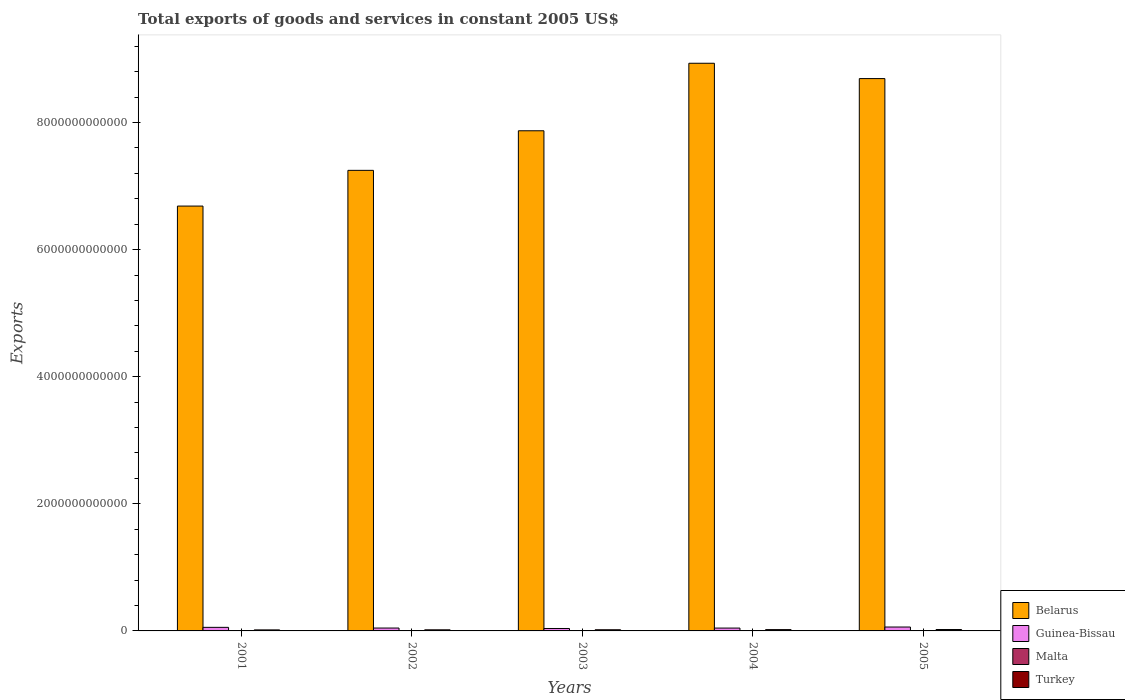Are the number of bars on each tick of the X-axis equal?
Offer a very short reply. Yes. What is the label of the 2nd group of bars from the left?
Your answer should be compact. 2002. What is the total exports of goods and services in Belarus in 2002?
Provide a succinct answer. 7.25e+12. Across all years, what is the maximum total exports of goods and services in Malta?
Give a very brief answer. 3.70e+09. Across all years, what is the minimum total exports of goods and services in Malta?
Offer a very short reply. 3.44e+09. What is the total total exports of goods and services in Guinea-Bissau in the graph?
Your answer should be compact. 2.46e+11. What is the difference between the total exports of goods and services in Malta in 2001 and that in 2002?
Your answer should be compact. -2.27e+08. What is the difference between the total exports of goods and services in Malta in 2005 and the total exports of goods and services in Guinea-Bissau in 2004?
Offer a very short reply. -4.11e+1. What is the average total exports of goods and services in Turkey per year?
Provide a short and direct response. 1.89e+1. In the year 2004, what is the difference between the total exports of goods and services in Belarus and total exports of goods and services in Guinea-Bissau?
Provide a succinct answer. 8.89e+12. What is the ratio of the total exports of goods and services in Belarus in 2001 to that in 2002?
Offer a very short reply. 0.92. Is the total exports of goods and services in Malta in 2001 less than that in 2004?
Offer a terse response. Yes. Is the difference between the total exports of goods and services in Belarus in 2002 and 2005 greater than the difference between the total exports of goods and services in Guinea-Bissau in 2002 and 2005?
Provide a succinct answer. No. What is the difference between the highest and the second highest total exports of goods and services in Turkey?
Your response must be concise. 1.62e+09. What is the difference between the highest and the lowest total exports of goods and services in Malta?
Provide a succinct answer. 2.62e+08. In how many years, is the total exports of goods and services in Malta greater than the average total exports of goods and services in Malta taken over all years?
Your answer should be compact. 3. Is the sum of the total exports of goods and services in Guinea-Bissau in 2004 and 2005 greater than the maximum total exports of goods and services in Turkey across all years?
Keep it short and to the point. Yes. What does the 3rd bar from the left in 2002 represents?
Your answer should be compact. Malta. What does the 4th bar from the right in 2004 represents?
Your answer should be very brief. Belarus. How many bars are there?
Ensure brevity in your answer.  20. How many years are there in the graph?
Your answer should be very brief. 5. What is the difference between two consecutive major ticks on the Y-axis?
Provide a short and direct response. 2.00e+12. Does the graph contain any zero values?
Offer a terse response. No. Where does the legend appear in the graph?
Make the answer very short. Bottom right. How many legend labels are there?
Provide a succinct answer. 4. How are the legend labels stacked?
Keep it short and to the point. Vertical. What is the title of the graph?
Give a very brief answer. Total exports of goods and services in constant 2005 US$. Does "Libya" appear as one of the legend labels in the graph?
Ensure brevity in your answer.  No. What is the label or title of the X-axis?
Your answer should be compact. Years. What is the label or title of the Y-axis?
Give a very brief answer. Exports. What is the Exports in Belarus in 2001?
Provide a short and direct response. 6.69e+12. What is the Exports of Guinea-Bissau in 2001?
Offer a terse response. 5.61e+1. What is the Exports of Malta in 2001?
Provide a short and direct response. 3.44e+09. What is the Exports in Turkey in 2001?
Offer a very short reply. 1.61e+1. What is the Exports of Belarus in 2002?
Offer a terse response. 7.25e+12. What is the Exports of Guinea-Bissau in 2002?
Ensure brevity in your answer.  4.53e+1. What is the Exports in Malta in 2002?
Provide a succinct answer. 3.67e+09. What is the Exports of Turkey in 2002?
Offer a very short reply. 1.72e+1. What is the Exports of Belarus in 2003?
Offer a terse response. 7.87e+12. What is the Exports in Guinea-Bissau in 2003?
Make the answer very short. 3.83e+1. What is the Exports of Malta in 2003?
Your response must be concise. 3.57e+09. What is the Exports in Turkey in 2003?
Make the answer very short. 1.84e+1. What is the Exports in Belarus in 2004?
Provide a short and direct response. 8.93e+12. What is the Exports of Guinea-Bissau in 2004?
Provide a succinct answer. 4.48e+1. What is the Exports in Malta in 2004?
Ensure brevity in your answer.  3.67e+09. What is the Exports in Turkey in 2004?
Keep it short and to the point. 2.05e+1. What is the Exports in Belarus in 2005?
Make the answer very short. 8.69e+12. What is the Exports in Guinea-Bissau in 2005?
Offer a terse response. 6.15e+1. What is the Exports in Malta in 2005?
Give a very brief answer. 3.70e+09. What is the Exports of Turkey in 2005?
Provide a short and direct response. 2.21e+1. Across all years, what is the maximum Exports of Belarus?
Offer a very short reply. 8.93e+12. Across all years, what is the maximum Exports of Guinea-Bissau?
Make the answer very short. 6.15e+1. Across all years, what is the maximum Exports of Malta?
Keep it short and to the point. 3.70e+09. Across all years, what is the maximum Exports in Turkey?
Ensure brevity in your answer.  2.21e+1. Across all years, what is the minimum Exports in Belarus?
Provide a short and direct response. 6.69e+12. Across all years, what is the minimum Exports of Guinea-Bissau?
Keep it short and to the point. 3.83e+1. Across all years, what is the minimum Exports in Malta?
Give a very brief answer. 3.44e+09. Across all years, what is the minimum Exports in Turkey?
Provide a short and direct response. 1.61e+1. What is the total Exports of Belarus in the graph?
Your response must be concise. 3.94e+13. What is the total Exports in Guinea-Bissau in the graph?
Give a very brief answer. 2.46e+11. What is the total Exports of Malta in the graph?
Offer a terse response. 1.81e+1. What is the total Exports in Turkey in the graph?
Make the answer very short. 9.44e+1. What is the difference between the Exports in Belarus in 2001 and that in 2002?
Your response must be concise. -5.62e+11. What is the difference between the Exports of Guinea-Bissau in 2001 and that in 2002?
Ensure brevity in your answer.  1.08e+1. What is the difference between the Exports of Malta in 2001 and that in 2002?
Offer a terse response. -2.27e+08. What is the difference between the Exports in Turkey in 2001 and that in 2002?
Your answer should be compact. -1.11e+09. What is the difference between the Exports in Belarus in 2001 and that in 2003?
Offer a terse response. -1.18e+12. What is the difference between the Exports of Guinea-Bissau in 2001 and that in 2003?
Offer a very short reply. 1.78e+1. What is the difference between the Exports in Malta in 2001 and that in 2003?
Make the answer very short. -1.33e+08. What is the difference between the Exports of Turkey in 2001 and that in 2003?
Give a very brief answer. -2.29e+09. What is the difference between the Exports of Belarus in 2001 and that in 2004?
Offer a very short reply. -2.25e+12. What is the difference between the Exports of Guinea-Bissau in 2001 and that in 2004?
Give a very brief answer. 1.13e+1. What is the difference between the Exports of Malta in 2001 and that in 2004?
Your response must be concise. -2.36e+08. What is the difference between the Exports in Turkey in 2001 and that in 2004?
Provide a short and direct response. -4.35e+09. What is the difference between the Exports in Belarus in 2001 and that in 2005?
Your answer should be very brief. -2.01e+12. What is the difference between the Exports in Guinea-Bissau in 2001 and that in 2005?
Make the answer very short. -5.32e+09. What is the difference between the Exports in Malta in 2001 and that in 2005?
Your answer should be compact. -2.62e+08. What is the difference between the Exports of Turkey in 2001 and that in 2005?
Your answer should be very brief. -5.97e+09. What is the difference between the Exports of Belarus in 2002 and that in 2003?
Ensure brevity in your answer.  -6.23e+11. What is the difference between the Exports in Guinea-Bissau in 2002 and that in 2003?
Offer a terse response. 7.01e+09. What is the difference between the Exports of Malta in 2002 and that in 2003?
Give a very brief answer. 9.46e+07. What is the difference between the Exports of Turkey in 2002 and that in 2003?
Provide a succinct answer. -1.18e+09. What is the difference between the Exports of Belarus in 2002 and that in 2004?
Provide a succinct answer. -1.69e+12. What is the difference between the Exports in Guinea-Bissau in 2002 and that in 2004?
Keep it short and to the point. 5.33e+08. What is the difference between the Exports of Malta in 2002 and that in 2004?
Your response must be concise. -8.52e+06. What is the difference between the Exports of Turkey in 2002 and that in 2004?
Keep it short and to the point. -3.24e+09. What is the difference between the Exports in Belarus in 2002 and that in 2005?
Ensure brevity in your answer.  -1.44e+12. What is the difference between the Exports in Guinea-Bissau in 2002 and that in 2005?
Your response must be concise. -1.61e+1. What is the difference between the Exports of Malta in 2002 and that in 2005?
Offer a terse response. -3.45e+07. What is the difference between the Exports in Turkey in 2002 and that in 2005?
Make the answer very short. -4.86e+09. What is the difference between the Exports in Belarus in 2003 and that in 2004?
Give a very brief answer. -1.06e+12. What is the difference between the Exports in Guinea-Bissau in 2003 and that in 2004?
Your answer should be compact. -6.48e+09. What is the difference between the Exports in Malta in 2003 and that in 2004?
Your answer should be compact. -1.03e+08. What is the difference between the Exports in Turkey in 2003 and that in 2004?
Your response must be concise. -2.06e+09. What is the difference between the Exports in Belarus in 2003 and that in 2005?
Ensure brevity in your answer.  -8.21e+11. What is the difference between the Exports of Guinea-Bissau in 2003 and that in 2005?
Your answer should be very brief. -2.31e+1. What is the difference between the Exports in Malta in 2003 and that in 2005?
Ensure brevity in your answer.  -1.29e+08. What is the difference between the Exports in Turkey in 2003 and that in 2005?
Provide a succinct answer. -3.67e+09. What is the difference between the Exports in Belarus in 2004 and that in 2005?
Offer a very short reply. 2.41e+11. What is the difference between the Exports of Guinea-Bissau in 2004 and that in 2005?
Your answer should be very brief. -1.66e+1. What is the difference between the Exports of Malta in 2004 and that in 2005?
Keep it short and to the point. -2.60e+07. What is the difference between the Exports of Turkey in 2004 and that in 2005?
Provide a succinct answer. -1.62e+09. What is the difference between the Exports of Belarus in 2001 and the Exports of Guinea-Bissau in 2002?
Offer a very short reply. 6.64e+12. What is the difference between the Exports of Belarus in 2001 and the Exports of Malta in 2002?
Your answer should be very brief. 6.68e+12. What is the difference between the Exports in Belarus in 2001 and the Exports in Turkey in 2002?
Your answer should be compact. 6.67e+12. What is the difference between the Exports in Guinea-Bissau in 2001 and the Exports in Malta in 2002?
Your response must be concise. 5.25e+1. What is the difference between the Exports of Guinea-Bissau in 2001 and the Exports of Turkey in 2002?
Offer a terse response. 3.89e+1. What is the difference between the Exports of Malta in 2001 and the Exports of Turkey in 2002?
Ensure brevity in your answer.  -1.38e+1. What is the difference between the Exports of Belarus in 2001 and the Exports of Guinea-Bissau in 2003?
Your answer should be very brief. 6.65e+12. What is the difference between the Exports of Belarus in 2001 and the Exports of Malta in 2003?
Provide a short and direct response. 6.68e+12. What is the difference between the Exports of Belarus in 2001 and the Exports of Turkey in 2003?
Ensure brevity in your answer.  6.67e+12. What is the difference between the Exports of Guinea-Bissau in 2001 and the Exports of Malta in 2003?
Offer a terse response. 5.26e+1. What is the difference between the Exports in Guinea-Bissau in 2001 and the Exports in Turkey in 2003?
Provide a short and direct response. 3.77e+1. What is the difference between the Exports in Malta in 2001 and the Exports in Turkey in 2003?
Your response must be concise. -1.50e+1. What is the difference between the Exports of Belarus in 2001 and the Exports of Guinea-Bissau in 2004?
Keep it short and to the point. 6.64e+12. What is the difference between the Exports of Belarus in 2001 and the Exports of Malta in 2004?
Keep it short and to the point. 6.68e+12. What is the difference between the Exports in Belarus in 2001 and the Exports in Turkey in 2004?
Your response must be concise. 6.67e+12. What is the difference between the Exports of Guinea-Bissau in 2001 and the Exports of Malta in 2004?
Ensure brevity in your answer.  5.25e+1. What is the difference between the Exports in Guinea-Bissau in 2001 and the Exports in Turkey in 2004?
Keep it short and to the point. 3.57e+1. What is the difference between the Exports of Malta in 2001 and the Exports of Turkey in 2004?
Provide a short and direct response. -1.70e+1. What is the difference between the Exports of Belarus in 2001 and the Exports of Guinea-Bissau in 2005?
Provide a succinct answer. 6.62e+12. What is the difference between the Exports of Belarus in 2001 and the Exports of Malta in 2005?
Make the answer very short. 6.68e+12. What is the difference between the Exports of Belarus in 2001 and the Exports of Turkey in 2005?
Your answer should be compact. 6.66e+12. What is the difference between the Exports in Guinea-Bissau in 2001 and the Exports in Malta in 2005?
Offer a terse response. 5.24e+1. What is the difference between the Exports in Guinea-Bissau in 2001 and the Exports in Turkey in 2005?
Make the answer very short. 3.40e+1. What is the difference between the Exports of Malta in 2001 and the Exports of Turkey in 2005?
Provide a succinct answer. -1.87e+1. What is the difference between the Exports of Belarus in 2002 and the Exports of Guinea-Bissau in 2003?
Make the answer very short. 7.21e+12. What is the difference between the Exports in Belarus in 2002 and the Exports in Malta in 2003?
Keep it short and to the point. 7.24e+12. What is the difference between the Exports in Belarus in 2002 and the Exports in Turkey in 2003?
Give a very brief answer. 7.23e+12. What is the difference between the Exports of Guinea-Bissau in 2002 and the Exports of Malta in 2003?
Provide a short and direct response. 4.18e+1. What is the difference between the Exports of Guinea-Bissau in 2002 and the Exports of Turkey in 2003?
Your answer should be very brief. 2.69e+1. What is the difference between the Exports of Malta in 2002 and the Exports of Turkey in 2003?
Your answer should be very brief. -1.48e+1. What is the difference between the Exports of Belarus in 2002 and the Exports of Guinea-Bissau in 2004?
Keep it short and to the point. 7.20e+12. What is the difference between the Exports in Belarus in 2002 and the Exports in Malta in 2004?
Make the answer very short. 7.24e+12. What is the difference between the Exports in Belarus in 2002 and the Exports in Turkey in 2004?
Make the answer very short. 7.23e+12. What is the difference between the Exports of Guinea-Bissau in 2002 and the Exports of Malta in 2004?
Make the answer very short. 4.17e+1. What is the difference between the Exports in Guinea-Bissau in 2002 and the Exports in Turkey in 2004?
Keep it short and to the point. 2.49e+1. What is the difference between the Exports of Malta in 2002 and the Exports of Turkey in 2004?
Your response must be concise. -1.68e+1. What is the difference between the Exports of Belarus in 2002 and the Exports of Guinea-Bissau in 2005?
Your answer should be very brief. 7.19e+12. What is the difference between the Exports in Belarus in 2002 and the Exports in Malta in 2005?
Your response must be concise. 7.24e+12. What is the difference between the Exports in Belarus in 2002 and the Exports in Turkey in 2005?
Your answer should be very brief. 7.23e+12. What is the difference between the Exports of Guinea-Bissau in 2002 and the Exports of Malta in 2005?
Make the answer very short. 4.16e+1. What is the difference between the Exports of Guinea-Bissau in 2002 and the Exports of Turkey in 2005?
Your response must be concise. 2.32e+1. What is the difference between the Exports of Malta in 2002 and the Exports of Turkey in 2005?
Your answer should be very brief. -1.84e+1. What is the difference between the Exports in Belarus in 2003 and the Exports in Guinea-Bissau in 2004?
Your answer should be very brief. 7.83e+12. What is the difference between the Exports of Belarus in 2003 and the Exports of Malta in 2004?
Offer a very short reply. 7.87e+12. What is the difference between the Exports of Belarus in 2003 and the Exports of Turkey in 2004?
Offer a very short reply. 7.85e+12. What is the difference between the Exports of Guinea-Bissau in 2003 and the Exports of Malta in 2004?
Offer a very short reply. 3.47e+1. What is the difference between the Exports in Guinea-Bissau in 2003 and the Exports in Turkey in 2004?
Your answer should be compact. 1.79e+1. What is the difference between the Exports in Malta in 2003 and the Exports in Turkey in 2004?
Keep it short and to the point. -1.69e+1. What is the difference between the Exports of Belarus in 2003 and the Exports of Guinea-Bissau in 2005?
Offer a very short reply. 7.81e+12. What is the difference between the Exports of Belarus in 2003 and the Exports of Malta in 2005?
Ensure brevity in your answer.  7.87e+12. What is the difference between the Exports in Belarus in 2003 and the Exports in Turkey in 2005?
Offer a terse response. 7.85e+12. What is the difference between the Exports of Guinea-Bissau in 2003 and the Exports of Malta in 2005?
Your response must be concise. 3.46e+1. What is the difference between the Exports in Guinea-Bissau in 2003 and the Exports in Turkey in 2005?
Offer a very short reply. 1.62e+1. What is the difference between the Exports in Malta in 2003 and the Exports in Turkey in 2005?
Give a very brief answer. -1.85e+1. What is the difference between the Exports in Belarus in 2004 and the Exports in Guinea-Bissau in 2005?
Your response must be concise. 8.87e+12. What is the difference between the Exports of Belarus in 2004 and the Exports of Malta in 2005?
Your answer should be compact. 8.93e+12. What is the difference between the Exports in Belarus in 2004 and the Exports in Turkey in 2005?
Your answer should be very brief. 8.91e+12. What is the difference between the Exports in Guinea-Bissau in 2004 and the Exports in Malta in 2005?
Provide a short and direct response. 4.11e+1. What is the difference between the Exports in Guinea-Bissau in 2004 and the Exports in Turkey in 2005?
Ensure brevity in your answer.  2.27e+1. What is the difference between the Exports of Malta in 2004 and the Exports of Turkey in 2005?
Offer a terse response. -1.84e+1. What is the average Exports of Belarus per year?
Keep it short and to the point. 7.89e+12. What is the average Exports in Guinea-Bissau per year?
Keep it short and to the point. 4.92e+1. What is the average Exports of Malta per year?
Your answer should be very brief. 3.61e+09. What is the average Exports of Turkey per year?
Offer a very short reply. 1.89e+1. In the year 2001, what is the difference between the Exports of Belarus and Exports of Guinea-Bissau?
Keep it short and to the point. 6.63e+12. In the year 2001, what is the difference between the Exports in Belarus and Exports in Malta?
Offer a terse response. 6.68e+12. In the year 2001, what is the difference between the Exports in Belarus and Exports in Turkey?
Your response must be concise. 6.67e+12. In the year 2001, what is the difference between the Exports in Guinea-Bissau and Exports in Malta?
Your answer should be very brief. 5.27e+1. In the year 2001, what is the difference between the Exports of Guinea-Bissau and Exports of Turkey?
Provide a succinct answer. 4.00e+1. In the year 2001, what is the difference between the Exports in Malta and Exports in Turkey?
Provide a succinct answer. -1.27e+1. In the year 2002, what is the difference between the Exports of Belarus and Exports of Guinea-Bissau?
Your answer should be very brief. 7.20e+12. In the year 2002, what is the difference between the Exports in Belarus and Exports in Malta?
Your answer should be compact. 7.24e+12. In the year 2002, what is the difference between the Exports in Belarus and Exports in Turkey?
Offer a very short reply. 7.23e+12. In the year 2002, what is the difference between the Exports in Guinea-Bissau and Exports in Malta?
Provide a succinct answer. 4.17e+1. In the year 2002, what is the difference between the Exports in Guinea-Bissau and Exports in Turkey?
Keep it short and to the point. 2.81e+1. In the year 2002, what is the difference between the Exports in Malta and Exports in Turkey?
Keep it short and to the point. -1.36e+1. In the year 2003, what is the difference between the Exports of Belarus and Exports of Guinea-Bissau?
Give a very brief answer. 7.83e+12. In the year 2003, what is the difference between the Exports in Belarus and Exports in Malta?
Provide a succinct answer. 7.87e+12. In the year 2003, what is the difference between the Exports in Belarus and Exports in Turkey?
Ensure brevity in your answer.  7.85e+12. In the year 2003, what is the difference between the Exports of Guinea-Bissau and Exports of Malta?
Ensure brevity in your answer.  3.48e+1. In the year 2003, what is the difference between the Exports in Guinea-Bissau and Exports in Turkey?
Your answer should be very brief. 1.99e+1. In the year 2003, what is the difference between the Exports of Malta and Exports of Turkey?
Offer a very short reply. -1.49e+1. In the year 2004, what is the difference between the Exports of Belarus and Exports of Guinea-Bissau?
Provide a succinct answer. 8.89e+12. In the year 2004, what is the difference between the Exports of Belarus and Exports of Malta?
Keep it short and to the point. 8.93e+12. In the year 2004, what is the difference between the Exports in Belarus and Exports in Turkey?
Provide a short and direct response. 8.91e+12. In the year 2004, what is the difference between the Exports in Guinea-Bissau and Exports in Malta?
Your response must be concise. 4.11e+1. In the year 2004, what is the difference between the Exports of Guinea-Bissau and Exports of Turkey?
Give a very brief answer. 2.43e+1. In the year 2004, what is the difference between the Exports of Malta and Exports of Turkey?
Your answer should be compact. -1.68e+1. In the year 2005, what is the difference between the Exports of Belarus and Exports of Guinea-Bissau?
Offer a very short reply. 8.63e+12. In the year 2005, what is the difference between the Exports of Belarus and Exports of Malta?
Make the answer very short. 8.69e+12. In the year 2005, what is the difference between the Exports in Belarus and Exports in Turkey?
Ensure brevity in your answer.  8.67e+12. In the year 2005, what is the difference between the Exports of Guinea-Bissau and Exports of Malta?
Provide a short and direct response. 5.78e+1. In the year 2005, what is the difference between the Exports in Guinea-Bissau and Exports in Turkey?
Your answer should be compact. 3.94e+1. In the year 2005, what is the difference between the Exports in Malta and Exports in Turkey?
Offer a very short reply. -1.84e+1. What is the ratio of the Exports of Belarus in 2001 to that in 2002?
Provide a short and direct response. 0.92. What is the ratio of the Exports in Guinea-Bissau in 2001 to that in 2002?
Keep it short and to the point. 1.24. What is the ratio of the Exports in Malta in 2001 to that in 2002?
Your answer should be compact. 0.94. What is the ratio of the Exports of Turkey in 2001 to that in 2002?
Your answer should be compact. 0.94. What is the ratio of the Exports of Belarus in 2001 to that in 2003?
Keep it short and to the point. 0.85. What is the ratio of the Exports of Guinea-Bissau in 2001 to that in 2003?
Your response must be concise. 1.46. What is the ratio of the Exports of Malta in 2001 to that in 2003?
Provide a short and direct response. 0.96. What is the ratio of the Exports of Turkey in 2001 to that in 2003?
Offer a very short reply. 0.88. What is the ratio of the Exports of Belarus in 2001 to that in 2004?
Your response must be concise. 0.75. What is the ratio of the Exports of Guinea-Bissau in 2001 to that in 2004?
Offer a terse response. 1.25. What is the ratio of the Exports in Malta in 2001 to that in 2004?
Offer a terse response. 0.94. What is the ratio of the Exports of Turkey in 2001 to that in 2004?
Your answer should be very brief. 0.79. What is the ratio of the Exports of Belarus in 2001 to that in 2005?
Offer a very short reply. 0.77. What is the ratio of the Exports of Guinea-Bissau in 2001 to that in 2005?
Your response must be concise. 0.91. What is the ratio of the Exports in Malta in 2001 to that in 2005?
Keep it short and to the point. 0.93. What is the ratio of the Exports in Turkey in 2001 to that in 2005?
Offer a very short reply. 0.73. What is the ratio of the Exports in Belarus in 2002 to that in 2003?
Offer a terse response. 0.92. What is the ratio of the Exports of Guinea-Bissau in 2002 to that in 2003?
Offer a very short reply. 1.18. What is the ratio of the Exports in Malta in 2002 to that in 2003?
Offer a very short reply. 1.03. What is the ratio of the Exports in Turkey in 2002 to that in 2003?
Your answer should be very brief. 0.94. What is the ratio of the Exports in Belarus in 2002 to that in 2004?
Provide a short and direct response. 0.81. What is the ratio of the Exports of Guinea-Bissau in 2002 to that in 2004?
Your response must be concise. 1.01. What is the ratio of the Exports in Turkey in 2002 to that in 2004?
Keep it short and to the point. 0.84. What is the ratio of the Exports of Belarus in 2002 to that in 2005?
Make the answer very short. 0.83. What is the ratio of the Exports in Guinea-Bissau in 2002 to that in 2005?
Ensure brevity in your answer.  0.74. What is the ratio of the Exports in Malta in 2002 to that in 2005?
Ensure brevity in your answer.  0.99. What is the ratio of the Exports of Turkey in 2002 to that in 2005?
Your answer should be very brief. 0.78. What is the ratio of the Exports of Belarus in 2003 to that in 2004?
Your response must be concise. 0.88. What is the ratio of the Exports in Guinea-Bissau in 2003 to that in 2004?
Ensure brevity in your answer.  0.86. What is the ratio of the Exports in Malta in 2003 to that in 2004?
Provide a short and direct response. 0.97. What is the ratio of the Exports in Turkey in 2003 to that in 2004?
Ensure brevity in your answer.  0.9. What is the ratio of the Exports in Belarus in 2003 to that in 2005?
Make the answer very short. 0.91. What is the ratio of the Exports of Guinea-Bissau in 2003 to that in 2005?
Ensure brevity in your answer.  0.62. What is the ratio of the Exports of Malta in 2003 to that in 2005?
Your answer should be very brief. 0.97. What is the ratio of the Exports of Turkey in 2003 to that in 2005?
Provide a succinct answer. 0.83. What is the ratio of the Exports of Belarus in 2004 to that in 2005?
Keep it short and to the point. 1.03. What is the ratio of the Exports of Guinea-Bissau in 2004 to that in 2005?
Provide a short and direct response. 0.73. What is the ratio of the Exports of Malta in 2004 to that in 2005?
Your answer should be very brief. 0.99. What is the ratio of the Exports in Turkey in 2004 to that in 2005?
Your response must be concise. 0.93. What is the difference between the highest and the second highest Exports of Belarus?
Give a very brief answer. 2.41e+11. What is the difference between the highest and the second highest Exports in Guinea-Bissau?
Ensure brevity in your answer.  5.32e+09. What is the difference between the highest and the second highest Exports in Malta?
Your answer should be compact. 2.60e+07. What is the difference between the highest and the second highest Exports in Turkey?
Provide a short and direct response. 1.62e+09. What is the difference between the highest and the lowest Exports of Belarus?
Give a very brief answer. 2.25e+12. What is the difference between the highest and the lowest Exports of Guinea-Bissau?
Keep it short and to the point. 2.31e+1. What is the difference between the highest and the lowest Exports in Malta?
Provide a short and direct response. 2.62e+08. What is the difference between the highest and the lowest Exports of Turkey?
Your response must be concise. 5.97e+09. 